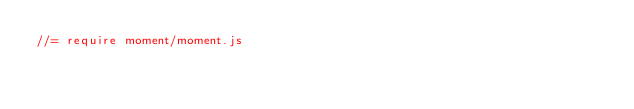Convert code to text. <code><loc_0><loc_0><loc_500><loc_500><_JavaScript_>//= require moment/moment.js
</code> 